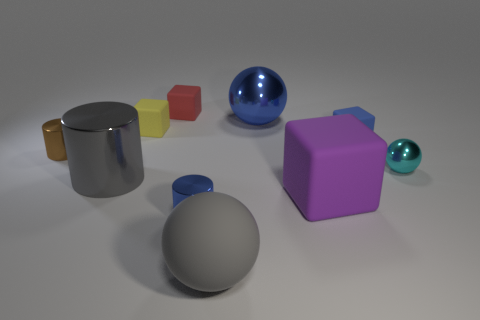Subtract 1 cubes. How many cubes are left? 3 Subtract all purple cubes. How many cubes are left? 3 Subtract all tiny cylinders. How many cylinders are left? 1 Subtract all cyan blocks. Subtract all cyan spheres. How many blocks are left? 4 Subtract all spheres. How many objects are left? 7 Subtract all tiny yellow cubes. Subtract all large cylinders. How many objects are left? 8 Add 9 big gray cylinders. How many big gray cylinders are left? 10 Add 1 tiny gray metal things. How many tiny gray metal things exist? 1 Subtract 0 cyan blocks. How many objects are left? 10 